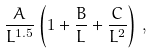Convert formula to latex. <formula><loc_0><loc_0><loc_500><loc_500>\frac { A } { L ^ { 1 . 5 } } \left ( 1 + \frac { B } { L } + \frac { C } { L ^ { 2 } } \right ) \, ,</formula> 